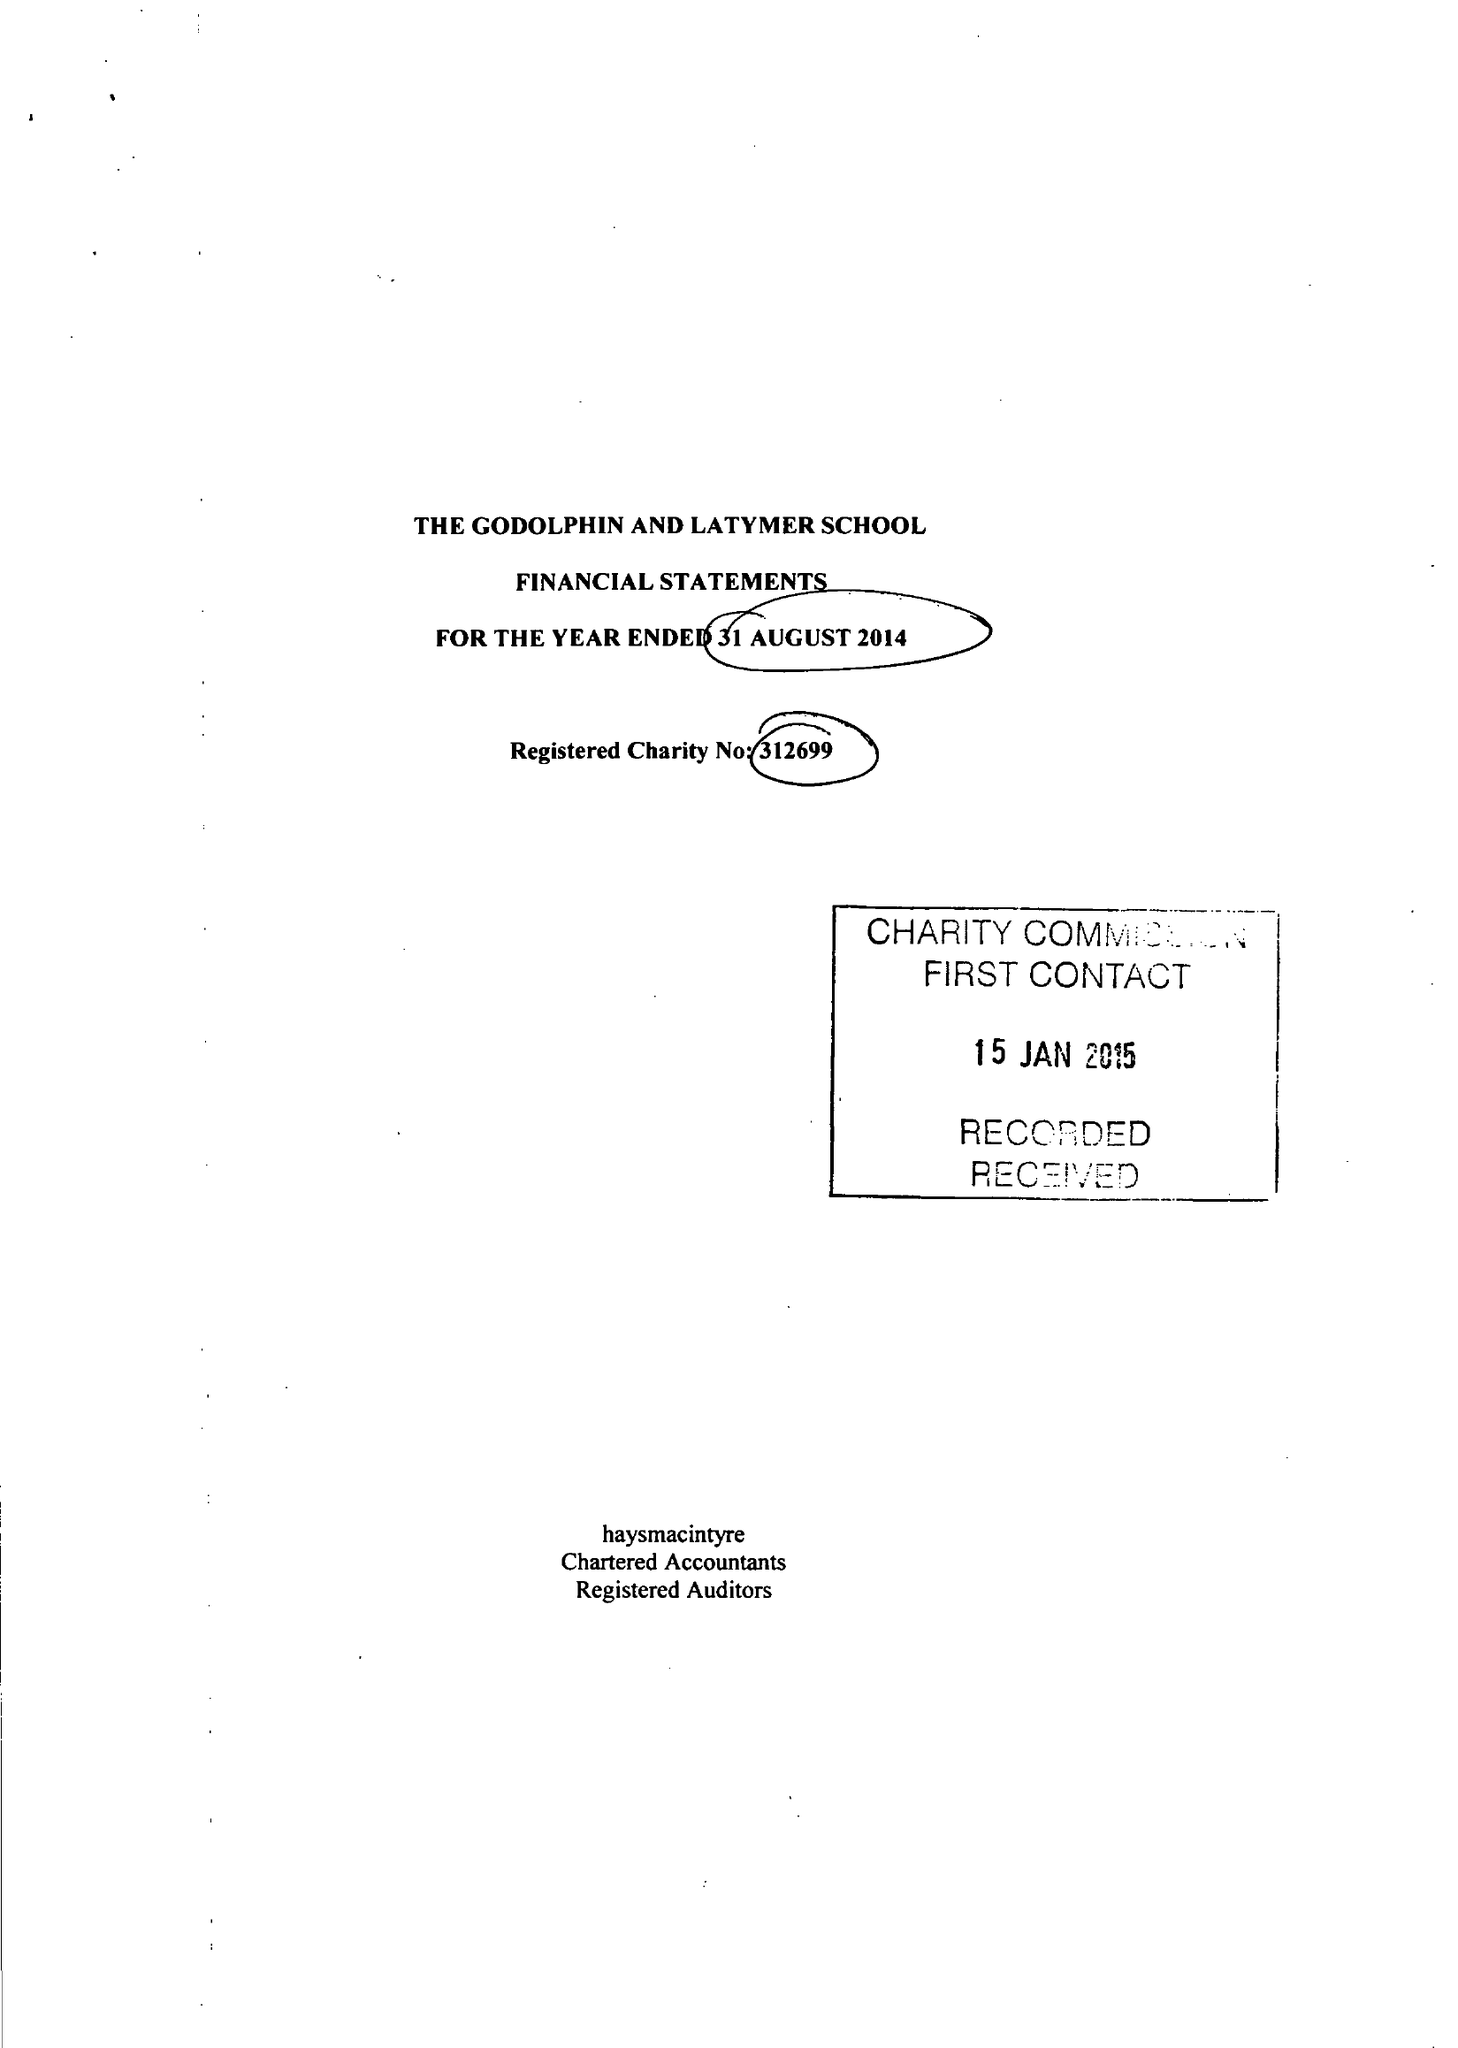What is the value for the charity_number?
Answer the question using a single word or phrase. 312699 